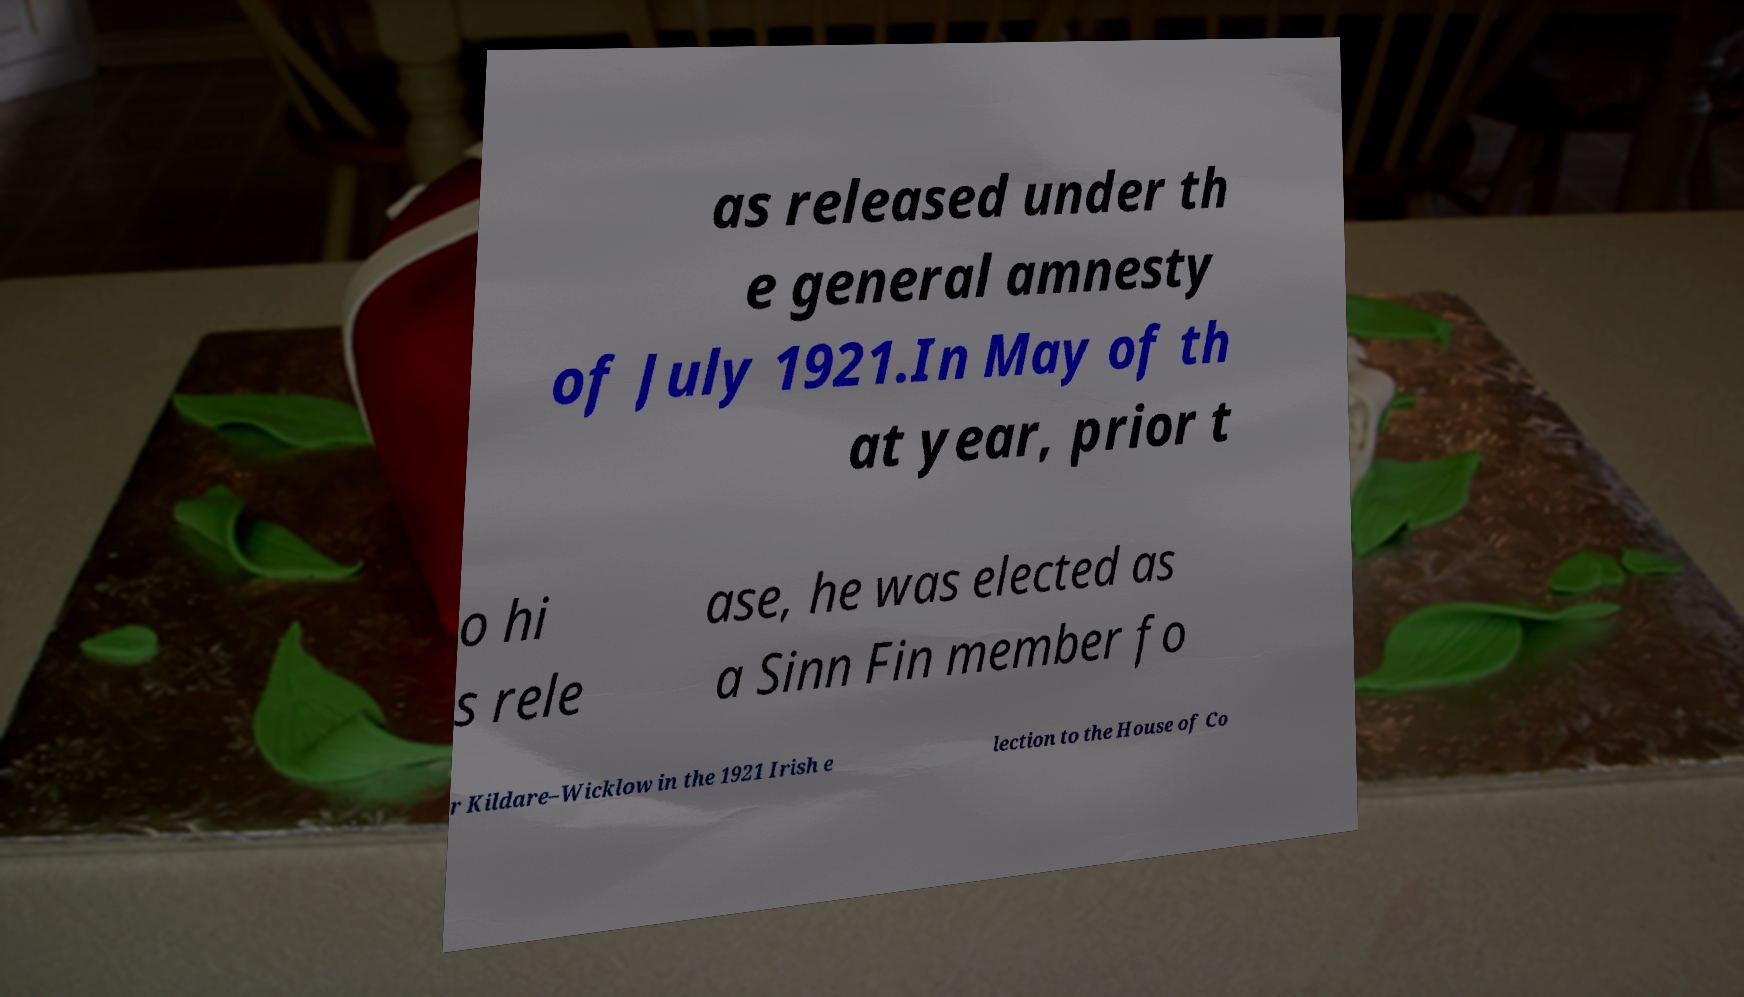What messages or text are displayed in this image? I need them in a readable, typed format. as released under th e general amnesty of July 1921.In May of th at year, prior t o hi s rele ase, he was elected as a Sinn Fin member fo r Kildare–Wicklow in the 1921 Irish e lection to the House of Co 